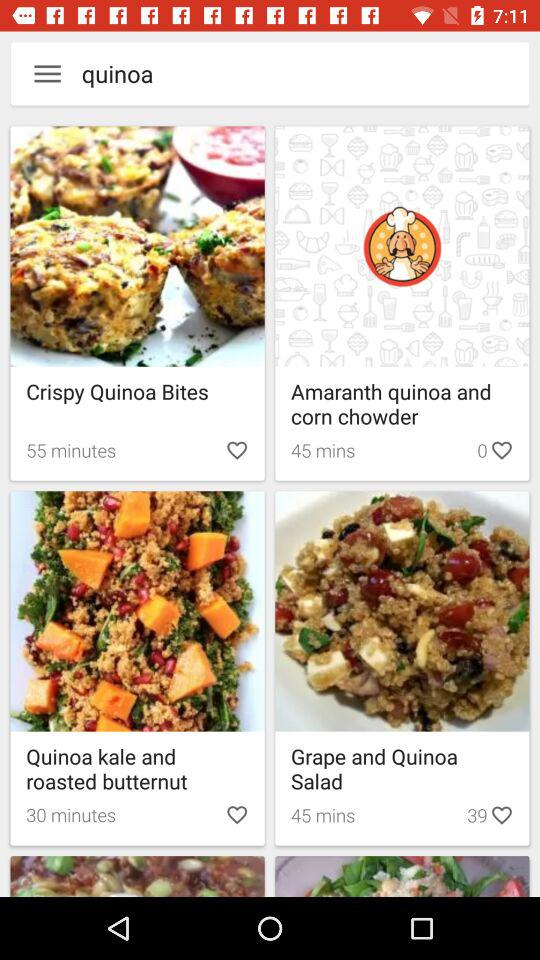How much time is required to make quinoa kale and roasted butternut?
When the provided information is insufficient, respond with <no answer>. <no answer> 